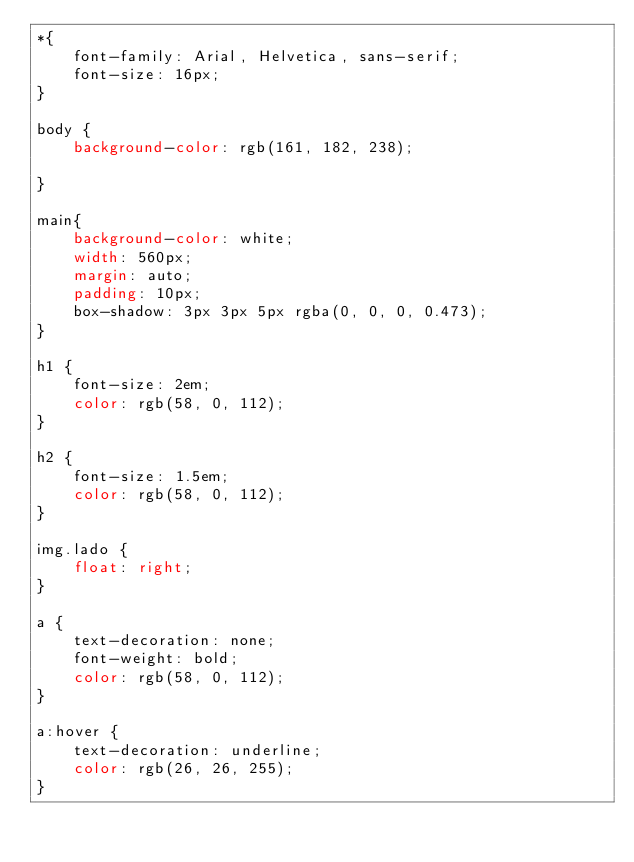<code> <loc_0><loc_0><loc_500><loc_500><_CSS_>*{
    font-family: Arial, Helvetica, sans-serif;
    font-size: 16px;
}

body {
    background-color: rgb(161, 182, 238);

}

main{
    background-color: white;
    width: 560px;
    margin: auto;
    padding: 10px;
    box-shadow: 3px 3px 5px rgba(0, 0, 0, 0.473);
}

h1 {
    font-size: 2em;
    color: rgb(58, 0, 112);
}

h2 {
    font-size: 1.5em;
    color: rgb(58, 0, 112);
}

img.lado {
    float: right;
}

a {
    text-decoration: none;
    font-weight: bold;
    color: rgb(58, 0, 112);
}

a:hover {
    text-decoration: underline;
    color: rgb(26, 26, 255);
}</code> 